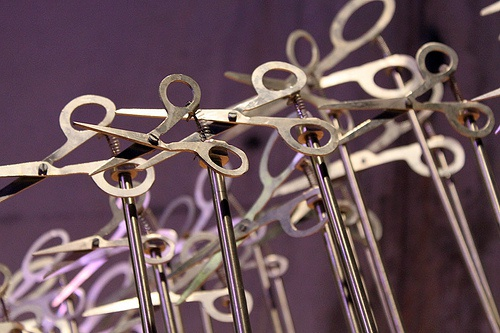Describe the objects in this image and their specific colors. I can see scissors in purple, darkgray, and pink tones, scissors in purple, ivory, darkgray, black, and tan tones, scissors in purple, ivory, and tan tones, scissors in purple, black, gray, and tan tones, and scissors in purple, gray, black, and maroon tones in this image. 